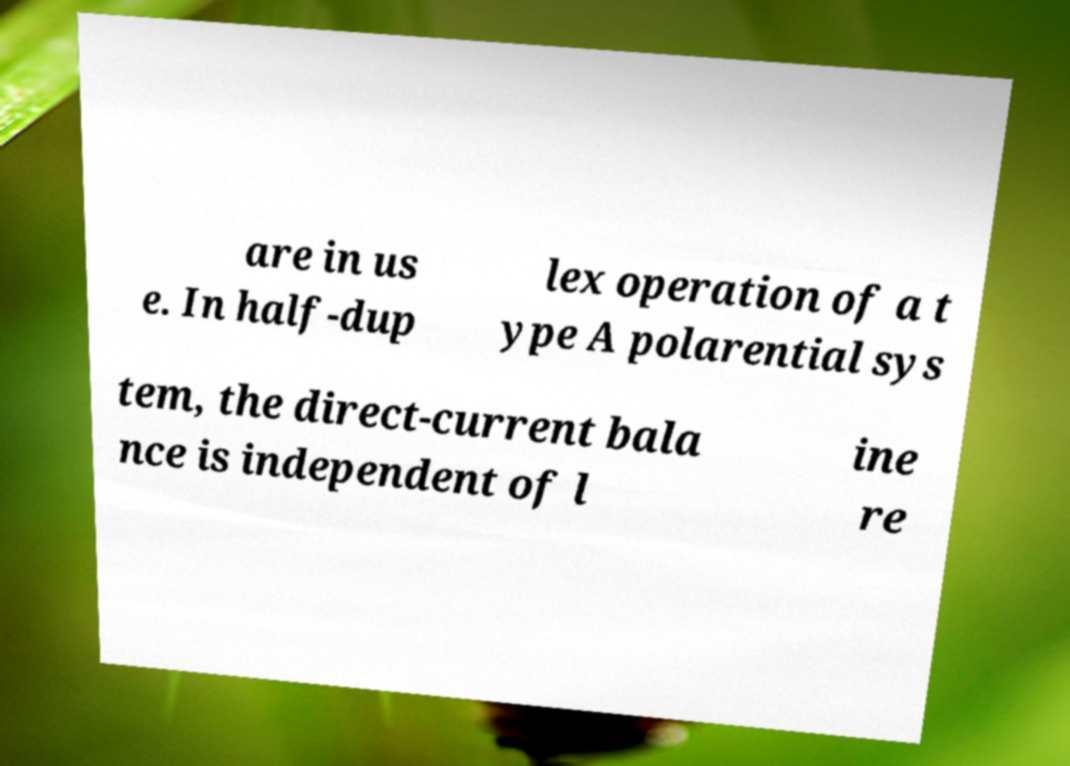Please read and relay the text visible in this image. What does it say? are in us e. In half-dup lex operation of a t ype A polarential sys tem, the direct-current bala nce is independent of l ine re 